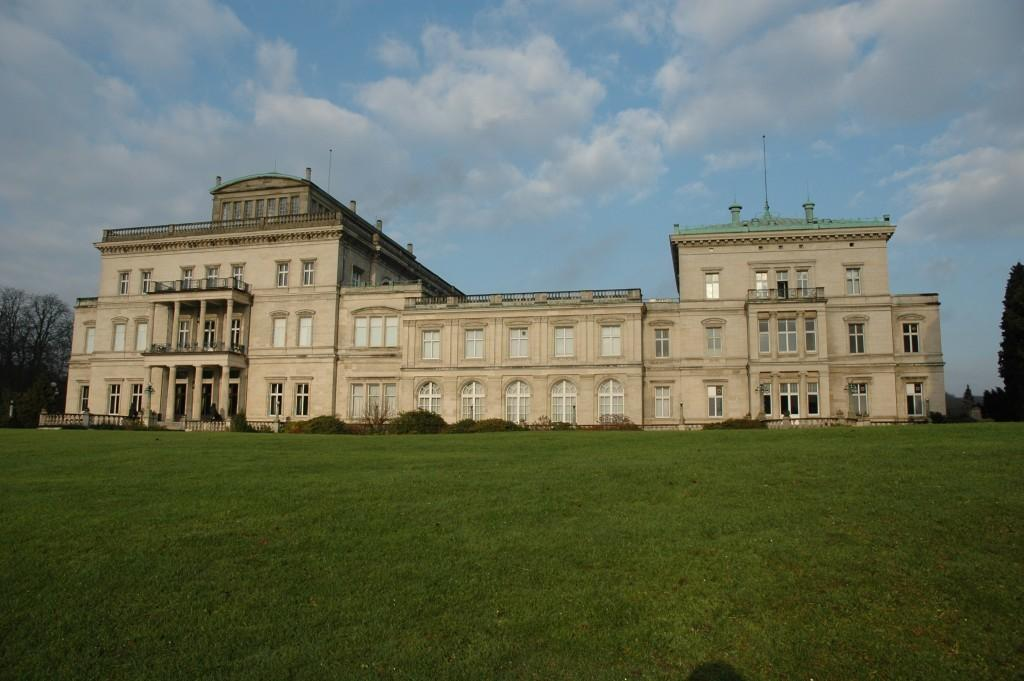What type of vegetation is visible in the front of the image? There is grass in the front of the image. What covers the land in the image? The land is covered with grass. What can be seen in the background of the image? There is a building, trees, plants, a railing, and objects in the background of the image. What is the condition of the sky in the image? The sky is cloudy in the background of the image. What type of rose is being discussed in the image? There is no rose or discussion present in the image. What color is the sky in the image? The sky is not mentioned in the provided facts, but it is described as cloudy in the background of the image. 